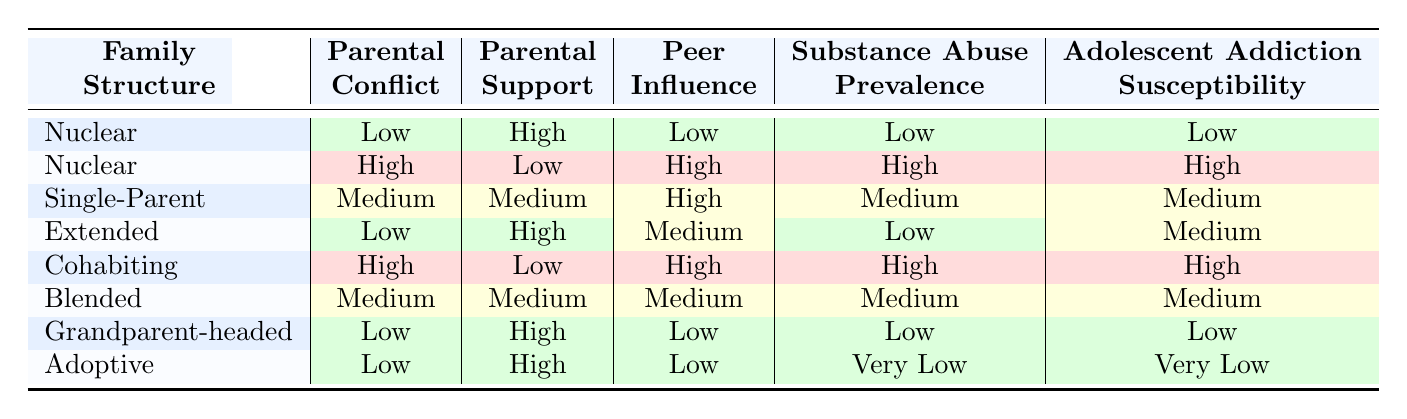What family structure is associated with low adolescent addiction susceptibility? By examining the table, we find that both the Nuclear and Grandparent-headed family structures are linked to low adolescent addiction susceptibility.
Answer: Nuclear and Grandparent-headed What is the parental conflict level in the cohabiting family structure? The table clearly indicates that the parental conflict level for cohabiting family structure is categorized as high.
Answer: High Is peer influence low in the adoptive family structure? According to the table, the peer influence level in the adoptive family structure is indeed low.
Answer: Yes What family structures have high parental support and low adolescent addiction susceptibility? The table shows that the Nuclear and Grandparent-headed family structures have high parental support and low adolescent addiction susceptibility.
Answer: Nuclear and Grandparent-headed What's the average substance abuse prevalence for family structures categorized as medium? From the table, the family structures with medium substance abuse prevalence are Single-Parent, Blended and Extended. Their values are Medium (1), Medium (1), Medium (1), summing them gives total (3), so the average = 3/3 = Medium.
Answer: Medium How many family structures have high parental conflict? The table lists cohabiting and nuclear family structures with high parental conflict. Counting these, we find there are two such structures.
Answer: 2 Are all family structures with high peer influence also linked to high adolescent addiction susceptibility? By examining the table, we find cohabiting and nuclear family structures have high peer influence and both are linked to high adolescent addiction susceptibility, while Single-Parent and Blended have medium influence without directly linking to high susceptibility, thus the answer is no.
Answer: No What relationships exist between parental support and adolescent addiction susceptibility across all family structures? Upon reviewing the data in the table, a pattern emerges: high parental support tends to correlate with low adolescent addiction susceptibility (as seen in Nuclear and Grandparent-headed), while low parental support pairs with high susceptibility (evident in the cohabiting and nuclear structures). This suggests a negative correlation between parental support and addiction susceptibility.
Answer: Negative correlation What family structure has both high peer influence and high adolescent addiction susceptibility? The table indicates that the cohabiting and nuclear family structures are characterized by high peer influence and high adolescent addiction susceptibility.
Answer: Cohabiting and Nuclear 